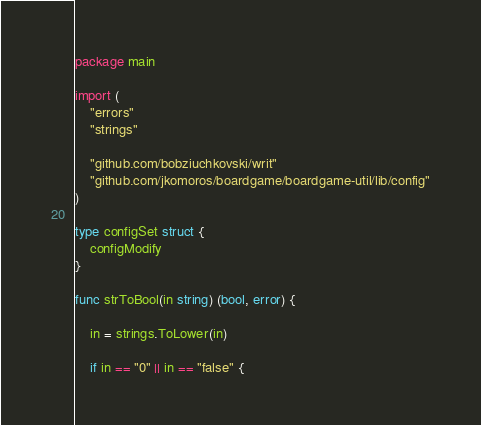<code> <loc_0><loc_0><loc_500><loc_500><_Go_>package main

import (
	"errors"
	"strings"

	"github.com/bobziuchkovski/writ"
	"github.com/jkomoros/boardgame/boardgame-util/lib/config"
)

type configSet struct {
	configModify
}

func strToBool(in string) (bool, error) {

	in = strings.ToLower(in)

	if in == "0" || in == "false" {</code> 